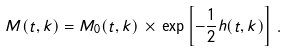<formula> <loc_0><loc_0><loc_500><loc_500>M ( t , k ) = M _ { 0 } ( t , k ) \, \times \, \exp \left [ - \frac { 1 } { 2 } h ( t , k ) \right ] \, .</formula> 